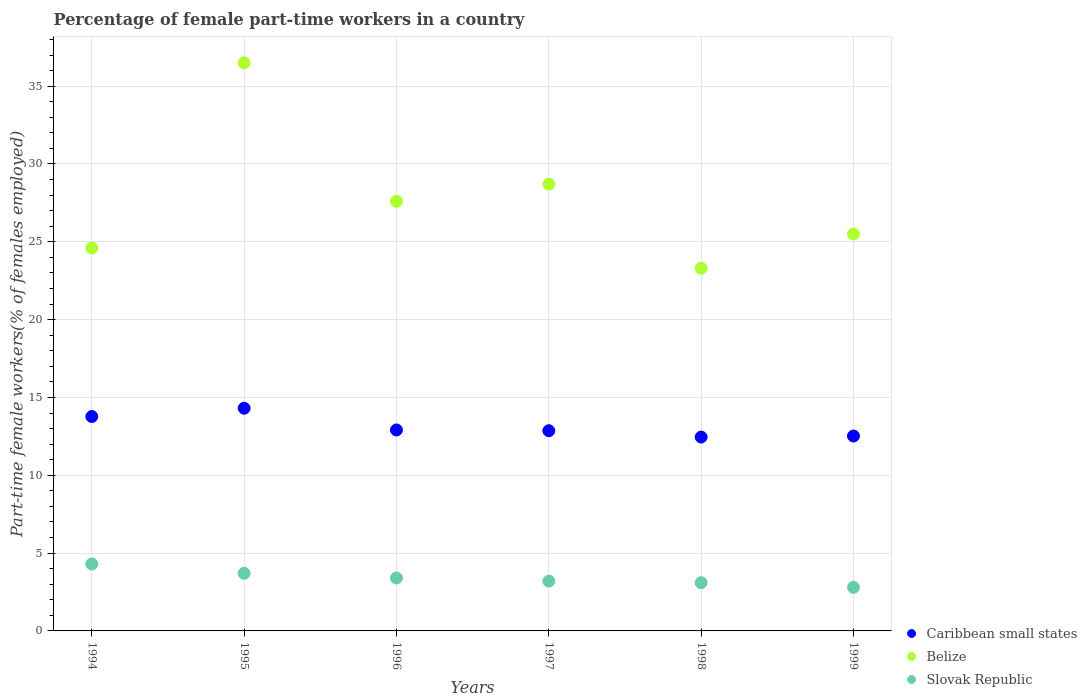Is the number of dotlines equal to the number of legend labels?
Offer a very short reply. Yes. What is the percentage of female part-time workers in Slovak Republic in 1999?
Your answer should be compact. 2.8. Across all years, what is the maximum percentage of female part-time workers in Slovak Republic?
Your answer should be very brief. 4.3. Across all years, what is the minimum percentage of female part-time workers in Slovak Republic?
Offer a very short reply. 2.8. In which year was the percentage of female part-time workers in Slovak Republic minimum?
Keep it short and to the point. 1999. What is the total percentage of female part-time workers in Slovak Republic in the graph?
Provide a short and direct response. 20.5. What is the difference between the percentage of female part-time workers in Caribbean small states in 1996 and that in 1997?
Give a very brief answer. 0.05. What is the difference between the percentage of female part-time workers in Belize in 1997 and the percentage of female part-time workers in Caribbean small states in 1999?
Make the answer very short. 16.18. What is the average percentage of female part-time workers in Caribbean small states per year?
Your answer should be compact. 13.14. In the year 1995, what is the difference between the percentage of female part-time workers in Slovak Republic and percentage of female part-time workers in Belize?
Provide a short and direct response. -32.8. In how many years, is the percentage of female part-time workers in Belize greater than 18 %?
Give a very brief answer. 6. What is the ratio of the percentage of female part-time workers in Slovak Republic in 1994 to that in 1999?
Offer a terse response. 1.54. Is the difference between the percentage of female part-time workers in Slovak Republic in 1996 and 1999 greater than the difference between the percentage of female part-time workers in Belize in 1996 and 1999?
Your answer should be compact. No. What is the difference between the highest and the second highest percentage of female part-time workers in Slovak Republic?
Give a very brief answer. 0.6. What is the difference between the highest and the lowest percentage of female part-time workers in Caribbean small states?
Offer a terse response. 1.85. In how many years, is the percentage of female part-time workers in Slovak Republic greater than the average percentage of female part-time workers in Slovak Republic taken over all years?
Offer a terse response. 2. Is the sum of the percentage of female part-time workers in Slovak Republic in 1996 and 1999 greater than the maximum percentage of female part-time workers in Belize across all years?
Provide a succinct answer. No. Does the percentage of female part-time workers in Belize monotonically increase over the years?
Your answer should be compact. No. Is the percentage of female part-time workers in Slovak Republic strictly less than the percentage of female part-time workers in Belize over the years?
Your answer should be very brief. Yes. What is the difference between two consecutive major ticks on the Y-axis?
Offer a very short reply. 5. How many legend labels are there?
Provide a short and direct response. 3. How are the legend labels stacked?
Ensure brevity in your answer.  Vertical. What is the title of the graph?
Provide a short and direct response. Percentage of female part-time workers in a country. What is the label or title of the Y-axis?
Offer a very short reply. Part-time female workers(% of females employed). What is the Part-time female workers(% of females employed) in Caribbean small states in 1994?
Keep it short and to the point. 13.77. What is the Part-time female workers(% of females employed) in Belize in 1994?
Keep it short and to the point. 24.6. What is the Part-time female workers(% of females employed) in Slovak Republic in 1994?
Your answer should be very brief. 4.3. What is the Part-time female workers(% of females employed) of Caribbean small states in 1995?
Make the answer very short. 14.31. What is the Part-time female workers(% of females employed) of Belize in 1995?
Your answer should be very brief. 36.5. What is the Part-time female workers(% of females employed) in Slovak Republic in 1995?
Your response must be concise. 3.7. What is the Part-time female workers(% of females employed) in Caribbean small states in 1996?
Provide a short and direct response. 12.91. What is the Part-time female workers(% of females employed) in Belize in 1996?
Your response must be concise. 27.6. What is the Part-time female workers(% of females employed) of Slovak Republic in 1996?
Offer a very short reply. 3.4. What is the Part-time female workers(% of females employed) in Caribbean small states in 1997?
Provide a succinct answer. 12.86. What is the Part-time female workers(% of females employed) of Belize in 1997?
Keep it short and to the point. 28.7. What is the Part-time female workers(% of females employed) in Slovak Republic in 1997?
Your response must be concise. 3.2. What is the Part-time female workers(% of females employed) of Caribbean small states in 1998?
Give a very brief answer. 12.45. What is the Part-time female workers(% of females employed) in Belize in 1998?
Give a very brief answer. 23.3. What is the Part-time female workers(% of females employed) of Slovak Republic in 1998?
Offer a very short reply. 3.1. What is the Part-time female workers(% of females employed) of Caribbean small states in 1999?
Give a very brief answer. 12.52. What is the Part-time female workers(% of females employed) of Belize in 1999?
Your response must be concise. 25.5. What is the Part-time female workers(% of females employed) of Slovak Republic in 1999?
Your answer should be compact. 2.8. Across all years, what is the maximum Part-time female workers(% of females employed) in Caribbean small states?
Your answer should be very brief. 14.31. Across all years, what is the maximum Part-time female workers(% of females employed) in Belize?
Your answer should be very brief. 36.5. Across all years, what is the maximum Part-time female workers(% of females employed) in Slovak Republic?
Your response must be concise. 4.3. Across all years, what is the minimum Part-time female workers(% of females employed) in Caribbean small states?
Ensure brevity in your answer.  12.45. Across all years, what is the minimum Part-time female workers(% of females employed) of Belize?
Your answer should be very brief. 23.3. Across all years, what is the minimum Part-time female workers(% of females employed) of Slovak Republic?
Make the answer very short. 2.8. What is the total Part-time female workers(% of females employed) in Caribbean small states in the graph?
Your answer should be compact. 78.83. What is the total Part-time female workers(% of females employed) of Belize in the graph?
Keep it short and to the point. 166.2. What is the difference between the Part-time female workers(% of females employed) in Caribbean small states in 1994 and that in 1995?
Provide a succinct answer. -0.53. What is the difference between the Part-time female workers(% of females employed) of Belize in 1994 and that in 1995?
Your answer should be compact. -11.9. What is the difference between the Part-time female workers(% of females employed) in Caribbean small states in 1994 and that in 1996?
Your answer should be very brief. 0.86. What is the difference between the Part-time female workers(% of females employed) in Slovak Republic in 1994 and that in 1996?
Your answer should be very brief. 0.9. What is the difference between the Part-time female workers(% of females employed) of Caribbean small states in 1994 and that in 1997?
Offer a terse response. 0.91. What is the difference between the Part-time female workers(% of females employed) of Slovak Republic in 1994 and that in 1997?
Offer a terse response. 1.1. What is the difference between the Part-time female workers(% of females employed) of Caribbean small states in 1994 and that in 1998?
Ensure brevity in your answer.  1.32. What is the difference between the Part-time female workers(% of females employed) in Belize in 1994 and that in 1998?
Give a very brief answer. 1.3. What is the difference between the Part-time female workers(% of females employed) in Slovak Republic in 1994 and that in 1998?
Provide a short and direct response. 1.2. What is the difference between the Part-time female workers(% of females employed) of Caribbean small states in 1994 and that in 1999?
Provide a short and direct response. 1.25. What is the difference between the Part-time female workers(% of females employed) in Belize in 1994 and that in 1999?
Ensure brevity in your answer.  -0.9. What is the difference between the Part-time female workers(% of females employed) in Slovak Republic in 1994 and that in 1999?
Provide a succinct answer. 1.5. What is the difference between the Part-time female workers(% of females employed) of Caribbean small states in 1995 and that in 1996?
Provide a short and direct response. 1.4. What is the difference between the Part-time female workers(% of females employed) in Slovak Republic in 1995 and that in 1996?
Provide a short and direct response. 0.3. What is the difference between the Part-time female workers(% of females employed) in Caribbean small states in 1995 and that in 1997?
Your answer should be compact. 1.45. What is the difference between the Part-time female workers(% of females employed) in Belize in 1995 and that in 1997?
Your answer should be compact. 7.8. What is the difference between the Part-time female workers(% of females employed) of Caribbean small states in 1995 and that in 1998?
Give a very brief answer. 1.85. What is the difference between the Part-time female workers(% of females employed) in Caribbean small states in 1995 and that in 1999?
Keep it short and to the point. 1.79. What is the difference between the Part-time female workers(% of females employed) in Slovak Republic in 1995 and that in 1999?
Your response must be concise. 0.9. What is the difference between the Part-time female workers(% of females employed) of Caribbean small states in 1996 and that in 1997?
Keep it short and to the point. 0.05. What is the difference between the Part-time female workers(% of females employed) of Belize in 1996 and that in 1997?
Your answer should be compact. -1.1. What is the difference between the Part-time female workers(% of females employed) of Slovak Republic in 1996 and that in 1997?
Offer a terse response. 0.2. What is the difference between the Part-time female workers(% of females employed) in Caribbean small states in 1996 and that in 1998?
Offer a very short reply. 0.46. What is the difference between the Part-time female workers(% of females employed) in Slovak Republic in 1996 and that in 1998?
Your response must be concise. 0.3. What is the difference between the Part-time female workers(% of females employed) of Caribbean small states in 1996 and that in 1999?
Provide a short and direct response. 0.39. What is the difference between the Part-time female workers(% of females employed) in Caribbean small states in 1997 and that in 1998?
Ensure brevity in your answer.  0.41. What is the difference between the Part-time female workers(% of females employed) in Caribbean small states in 1997 and that in 1999?
Ensure brevity in your answer.  0.34. What is the difference between the Part-time female workers(% of females employed) in Caribbean small states in 1998 and that in 1999?
Make the answer very short. -0.07. What is the difference between the Part-time female workers(% of females employed) of Slovak Republic in 1998 and that in 1999?
Give a very brief answer. 0.3. What is the difference between the Part-time female workers(% of females employed) in Caribbean small states in 1994 and the Part-time female workers(% of females employed) in Belize in 1995?
Make the answer very short. -22.73. What is the difference between the Part-time female workers(% of females employed) in Caribbean small states in 1994 and the Part-time female workers(% of females employed) in Slovak Republic in 1995?
Give a very brief answer. 10.07. What is the difference between the Part-time female workers(% of females employed) in Belize in 1994 and the Part-time female workers(% of females employed) in Slovak Republic in 1995?
Provide a succinct answer. 20.9. What is the difference between the Part-time female workers(% of females employed) of Caribbean small states in 1994 and the Part-time female workers(% of females employed) of Belize in 1996?
Provide a short and direct response. -13.83. What is the difference between the Part-time female workers(% of females employed) in Caribbean small states in 1994 and the Part-time female workers(% of females employed) in Slovak Republic in 1996?
Provide a succinct answer. 10.37. What is the difference between the Part-time female workers(% of females employed) in Belize in 1994 and the Part-time female workers(% of females employed) in Slovak Republic in 1996?
Ensure brevity in your answer.  21.2. What is the difference between the Part-time female workers(% of females employed) of Caribbean small states in 1994 and the Part-time female workers(% of females employed) of Belize in 1997?
Your answer should be very brief. -14.93. What is the difference between the Part-time female workers(% of females employed) of Caribbean small states in 1994 and the Part-time female workers(% of females employed) of Slovak Republic in 1997?
Offer a very short reply. 10.57. What is the difference between the Part-time female workers(% of females employed) in Belize in 1994 and the Part-time female workers(% of females employed) in Slovak Republic in 1997?
Keep it short and to the point. 21.4. What is the difference between the Part-time female workers(% of females employed) in Caribbean small states in 1994 and the Part-time female workers(% of females employed) in Belize in 1998?
Your answer should be compact. -9.53. What is the difference between the Part-time female workers(% of females employed) in Caribbean small states in 1994 and the Part-time female workers(% of females employed) in Slovak Republic in 1998?
Make the answer very short. 10.67. What is the difference between the Part-time female workers(% of females employed) in Caribbean small states in 1994 and the Part-time female workers(% of females employed) in Belize in 1999?
Make the answer very short. -11.73. What is the difference between the Part-time female workers(% of females employed) in Caribbean small states in 1994 and the Part-time female workers(% of females employed) in Slovak Republic in 1999?
Provide a short and direct response. 10.97. What is the difference between the Part-time female workers(% of females employed) in Belize in 1994 and the Part-time female workers(% of females employed) in Slovak Republic in 1999?
Your response must be concise. 21.8. What is the difference between the Part-time female workers(% of females employed) of Caribbean small states in 1995 and the Part-time female workers(% of females employed) of Belize in 1996?
Ensure brevity in your answer.  -13.29. What is the difference between the Part-time female workers(% of females employed) of Caribbean small states in 1995 and the Part-time female workers(% of females employed) of Slovak Republic in 1996?
Make the answer very short. 10.91. What is the difference between the Part-time female workers(% of females employed) of Belize in 1995 and the Part-time female workers(% of females employed) of Slovak Republic in 1996?
Keep it short and to the point. 33.1. What is the difference between the Part-time female workers(% of females employed) in Caribbean small states in 1995 and the Part-time female workers(% of females employed) in Belize in 1997?
Your response must be concise. -14.39. What is the difference between the Part-time female workers(% of females employed) in Caribbean small states in 1995 and the Part-time female workers(% of females employed) in Slovak Republic in 1997?
Make the answer very short. 11.11. What is the difference between the Part-time female workers(% of females employed) of Belize in 1995 and the Part-time female workers(% of females employed) of Slovak Republic in 1997?
Your response must be concise. 33.3. What is the difference between the Part-time female workers(% of females employed) of Caribbean small states in 1995 and the Part-time female workers(% of females employed) of Belize in 1998?
Your answer should be very brief. -8.99. What is the difference between the Part-time female workers(% of females employed) of Caribbean small states in 1995 and the Part-time female workers(% of females employed) of Slovak Republic in 1998?
Offer a very short reply. 11.21. What is the difference between the Part-time female workers(% of females employed) in Belize in 1995 and the Part-time female workers(% of females employed) in Slovak Republic in 1998?
Ensure brevity in your answer.  33.4. What is the difference between the Part-time female workers(% of females employed) in Caribbean small states in 1995 and the Part-time female workers(% of females employed) in Belize in 1999?
Provide a short and direct response. -11.19. What is the difference between the Part-time female workers(% of females employed) in Caribbean small states in 1995 and the Part-time female workers(% of females employed) in Slovak Republic in 1999?
Offer a very short reply. 11.51. What is the difference between the Part-time female workers(% of females employed) in Belize in 1995 and the Part-time female workers(% of females employed) in Slovak Republic in 1999?
Make the answer very short. 33.7. What is the difference between the Part-time female workers(% of females employed) in Caribbean small states in 1996 and the Part-time female workers(% of females employed) in Belize in 1997?
Your answer should be compact. -15.79. What is the difference between the Part-time female workers(% of females employed) in Caribbean small states in 1996 and the Part-time female workers(% of females employed) in Slovak Republic in 1997?
Your answer should be compact. 9.71. What is the difference between the Part-time female workers(% of females employed) of Belize in 1996 and the Part-time female workers(% of females employed) of Slovak Republic in 1997?
Offer a very short reply. 24.4. What is the difference between the Part-time female workers(% of females employed) in Caribbean small states in 1996 and the Part-time female workers(% of females employed) in Belize in 1998?
Provide a succinct answer. -10.39. What is the difference between the Part-time female workers(% of females employed) of Caribbean small states in 1996 and the Part-time female workers(% of females employed) of Slovak Republic in 1998?
Keep it short and to the point. 9.81. What is the difference between the Part-time female workers(% of females employed) of Caribbean small states in 1996 and the Part-time female workers(% of females employed) of Belize in 1999?
Offer a terse response. -12.59. What is the difference between the Part-time female workers(% of females employed) of Caribbean small states in 1996 and the Part-time female workers(% of females employed) of Slovak Republic in 1999?
Provide a short and direct response. 10.11. What is the difference between the Part-time female workers(% of females employed) of Belize in 1996 and the Part-time female workers(% of females employed) of Slovak Republic in 1999?
Your response must be concise. 24.8. What is the difference between the Part-time female workers(% of females employed) of Caribbean small states in 1997 and the Part-time female workers(% of females employed) of Belize in 1998?
Ensure brevity in your answer.  -10.44. What is the difference between the Part-time female workers(% of females employed) in Caribbean small states in 1997 and the Part-time female workers(% of females employed) in Slovak Republic in 1998?
Keep it short and to the point. 9.76. What is the difference between the Part-time female workers(% of females employed) of Belize in 1997 and the Part-time female workers(% of females employed) of Slovak Republic in 1998?
Offer a very short reply. 25.6. What is the difference between the Part-time female workers(% of females employed) of Caribbean small states in 1997 and the Part-time female workers(% of females employed) of Belize in 1999?
Offer a terse response. -12.64. What is the difference between the Part-time female workers(% of females employed) of Caribbean small states in 1997 and the Part-time female workers(% of females employed) of Slovak Republic in 1999?
Make the answer very short. 10.06. What is the difference between the Part-time female workers(% of females employed) in Belize in 1997 and the Part-time female workers(% of females employed) in Slovak Republic in 1999?
Ensure brevity in your answer.  25.9. What is the difference between the Part-time female workers(% of females employed) in Caribbean small states in 1998 and the Part-time female workers(% of females employed) in Belize in 1999?
Provide a succinct answer. -13.05. What is the difference between the Part-time female workers(% of females employed) in Caribbean small states in 1998 and the Part-time female workers(% of females employed) in Slovak Republic in 1999?
Your answer should be very brief. 9.65. What is the average Part-time female workers(% of females employed) of Caribbean small states per year?
Keep it short and to the point. 13.14. What is the average Part-time female workers(% of females employed) of Belize per year?
Keep it short and to the point. 27.7. What is the average Part-time female workers(% of females employed) of Slovak Republic per year?
Provide a succinct answer. 3.42. In the year 1994, what is the difference between the Part-time female workers(% of females employed) in Caribbean small states and Part-time female workers(% of females employed) in Belize?
Provide a succinct answer. -10.83. In the year 1994, what is the difference between the Part-time female workers(% of females employed) of Caribbean small states and Part-time female workers(% of females employed) of Slovak Republic?
Offer a terse response. 9.47. In the year 1994, what is the difference between the Part-time female workers(% of females employed) of Belize and Part-time female workers(% of females employed) of Slovak Republic?
Offer a very short reply. 20.3. In the year 1995, what is the difference between the Part-time female workers(% of females employed) of Caribbean small states and Part-time female workers(% of females employed) of Belize?
Give a very brief answer. -22.19. In the year 1995, what is the difference between the Part-time female workers(% of females employed) of Caribbean small states and Part-time female workers(% of females employed) of Slovak Republic?
Your answer should be compact. 10.61. In the year 1995, what is the difference between the Part-time female workers(% of females employed) in Belize and Part-time female workers(% of females employed) in Slovak Republic?
Your answer should be compact. 32.8. In the year 1996, what is the difference between the Part-time female workers(% of females employed) in Caribbean small states and Part-time female workers(% of females employed) in Belize?
Offer a terse response. -14.69. In the year 1996, what is the difference between the Part-time female workers(% of females employed) in Caribbean small states and Part-time female workers(% of females employed) in Slovak Republic?
Your response must be concise. 9.51. In the year 1996, what is the difference between the Part-time female workers(% of females employed) of Belize and Part-time female workers(% of females employed) of Slovak Republic?
Offer a very short reply. 24.2. In the year 1997, what is the difference between the Part-time female workers(% of females employed) of Caribbean small states and Part-time female workers(% of females employed) of Belize?
Offer a very short reply. -15.84. In the year 1997, what is the difference between the Part-time female workers(% of females employed) of Caribbean small states and Part-time female workers(% of females employed) of Slovak Republic?
Keep it short and to the point. 9.66. In the year 1997, what is the difference between the Part-time female workers(% of females employed) in Belize and Part-time female workers(% of females employed) in Slovak Republic?
Offer a terse response. 25.5. In the year 1998, what is the difference between the Part-time female workers(% of females employed) in Caribbean small states and Part-time female workers(% of females employed) in Belize?
Ensure brevity in your answer.  -10.85. In the year 1998, what is the difference between the Part-time female workers(% of females employed) in Caribbean small states and Part-time female workers(% of females employed) in Slovak Republic?
Provide a short and direct response. 9.35. In the year 1998, what is the difference between the Part-time female workers(% of females employed) in Belize and Part-time female workers(% of females employed) in Slovak Republic?
Offer a terse response. 20.2. In the year 1999, what is the difference between the Part-time female workers(% of females employed) of Caribbean small states and Part-time female workers(% of females employed) of Belize?
Offer a terse response. -12.98. In the year 1999, what is the difference between the Part-time female workers(% of females employed) of Caribbean small states and Part-time female workers(% of females employed) of Slovak Republic?
Offer a very short reply. 9.72. In the year 1999, what is the difference between the Part-time female workers(% of females employed) of Belize and Part-time female workers(% of females employed) of Slovak Republic?
Provide a short and direct response. 22.7. What is the ratio of the Part-time female workers(% of females employed) of Caribbean small states in 1994 to that in 1995?
Offer a very short reply. 0.96. What is the ratio of the Part-time female workers(% of females employed) of Belize in 1994 to that in 1995?
Keep it short and to the point. 0.67. What is the ratio of the Part-time female workers(% of females employed) of Slovak Republic in 1994 to that in 1995?
Ensure brevity in your answer.  1.16. What is the ratio of the Part-time female workers(% of females employed) in Caribbean small states in 1994 to that in 1996?
Your response must be concise. 1.07. What is the ratio of the Part-time female workers(% of females employed) of Belize in 1994 to that in 1996?
Ensure brevity in your answer.  0.89. What is the ratio of the Part-time female workers(% of females employed) in Slovak Republic in 1994 to that in 1996?
Give a very brief answer. 1.26. What is the ratio of the Part-time female workers(% of females employed) of Caribbean small states in 1994 to that in 1997?
Keep it short and to the point. 1.07. What is the ratio of the Part-time female workers(% of females employed) of Belize in 1994 to that in 1997?
Your answer should be very brief. 0.86. What is the ratio of the Part-time female workers(% of females employed) in Slovak Republic in 1994 to that in 1997?
Offer a very short reply. 1.34. What is the ratio of the Part-time female workers(% of females employed) of Caribbean small states in 1994 to that in 1998?
Provide a short and direct response. 1.11. What is the ratio of the Part-time female workers(% of females employed) in Belize in 1994 to that in 1998?
Give a very brief answer. 1.06. What is the ratio of the Part-time female workers(% of females employed) in Slovak Republic in 1994 to that in 1998?
Provide a short and direct response. 1.39. What is the ratio of the Part-time female workers(% of females employed) of Belize in 1994 to that in 1999?
Make the answer very short. 0.96. What is the ratio of the Part-time female workers(% of females employed) of Slovak Republic in 1994 to that in 1999?
Provide a short and direct response. 1.54. What is the ratio of the Part-time female workers(% of females employed) in Caribbean small states in 1995 to that in 1996?
Your answer should be compact. 1.11. What is the ratio of the Part-time female workers(% of females employed) in Belize in 1995 to that in 1996?
Offer a very short reply. 1.32. What is the ratio of the Part-time female workers(% of females employed) of Slovak Republic in 1995 to that in 1996?
Keep it short and to the point. 1.09. What is the ratio of the Part-time female workers(% of females employed) in Caribbean small states in 1995 to that in 1997?
Offer a terse response. 1.11. What is the ratio of the Part-time female workers(% of females employed) of Belize in 1995 to that in 1997?
Give a very brief answer. 1.27. What is the ratio of the Part-time female workers(% of females employed) of Slovak Republic in 1995 to that in 1997?
Keep it short and to the point. 1.16. What is the ratio of the Part-time female workers(% of females employed) of Caribbean small states in 1995 to that in 1998?
Provide a short and direct response. 1.15. What is the ratio of the Part-time female workers(% of females employed) in Belize in 1995 to that in 1998?
Your answer should be compact. 1.57. What is the ratio of the Part-time female workers(% of females employed) of Slovak Republic in 1995 to that in 1998?
Give a very brief answer. 1.19. What is the ratio of the Part-time female workers(% of females employed) in Caribbean small states in 1995 to that in 1999?
Your answer should be very brief. 1.14. What is the ratio of the Part-time female workers(% of females employed) of Belize in 1995 to that in 1999?
Offer a terse response. 1.43. What is the ratio of the Part-time female workers(% of females employed) in Slovak Republic in 1995 to that in 1999?
Provide a short and direct response. 1.32. What is the ratio of the Part-time female workers(% of females employed) in Belize in 1996 to that in 1997?
Your response must be concise. 0.96. What is the ratio of the Part-time female workers(% of females employed) in Caribbean small states in 1996 to that in 1998?
Provide a short and direct response. 1.04. What is the ratio of the Part-time female workers(% of females employed) of Belize in 1996 to that in 1998?
Offer a very short reply. 1.18. What is the ratio of the Part-time female workers(% of females employed) in Slovak Republic in 1996 to that in 1998?
Keep it short and to the point. 1.1. What is the ratio of the Part-time female workers(% of females employed) in Caribbean small states in 1996 to that in 1999?
Your answer should be very brief. 1.03. What is the ratio of the Part-time female workers(% of females employed) of Belize in 1996 to that in 1999?
Give a very brief answer. 1.08. What is the ratio of the Part-time female workers(% of females employed) in Slovak Republic in 1996 to that in 1999?
Offer a terse response. 1.21. What is the ratio of the Part-time female workers(% of females employed) in Caribbean small states in 1997 to that in 1998?
Provide a short and direct response. 1.03. What is the ratio of the Part-time female workers(% of females employed) of Belize in 1997 to that in 1998?
Make the answer very short. 1.23. What is the ratio of the Part-time female workers(% of females employed) in Slovak Republic in 1997 to that in 1998?
Your response must be concise. 1.03. What is the ratio of the Part-time female workers(% of females employed) in Caribbean small states in 1997 to that in 1999?
Provide a short and direct response. 1.03. What is the ratio of the Part-time female workers(% of females employed) in Belize in 1997 to that in 1999?
Ensure brevity in your answer.  1.13. What is the ratio of the Part-time female workers(% of females employed) in Slovak Republic in 1997 to that in 1999?
Provide a short and direct response. 1.14. What is the ratio of the Part-time female workers(% of females employed) in Caribbean small states in 1998 to that in 1999?
Your response must be concise. 0.99. What is the ratio of the Part-time female workers(% of females employed) of Belize in 1998 to that in 1999?
Provide a short and direct response. 0.91. What is the ratio of the Part-time female workers(% of females employed) of Slovak Republic in 1998 to that in 1999?
Keep it short and to the point. 1.11. What is the difference between the highest and the second highest Part-time female workers(% of females employed) in Caribbean small states?
Make the answer very short. 0.53. What is the difference between the highest and the lowest Part-time female workers(% of females employed) in Caribbean small states?
Provide a succinct answer. 1.85. What is the difference between the highest and the lowest Part-time female workers(% of females employed) in Belize?
Your answer should be very brief. 13.2. What is the difference between the highest and the lowest Part-time female workers(% of females employed) of Slovak Republic?
Make the answer very short. 1.5. 